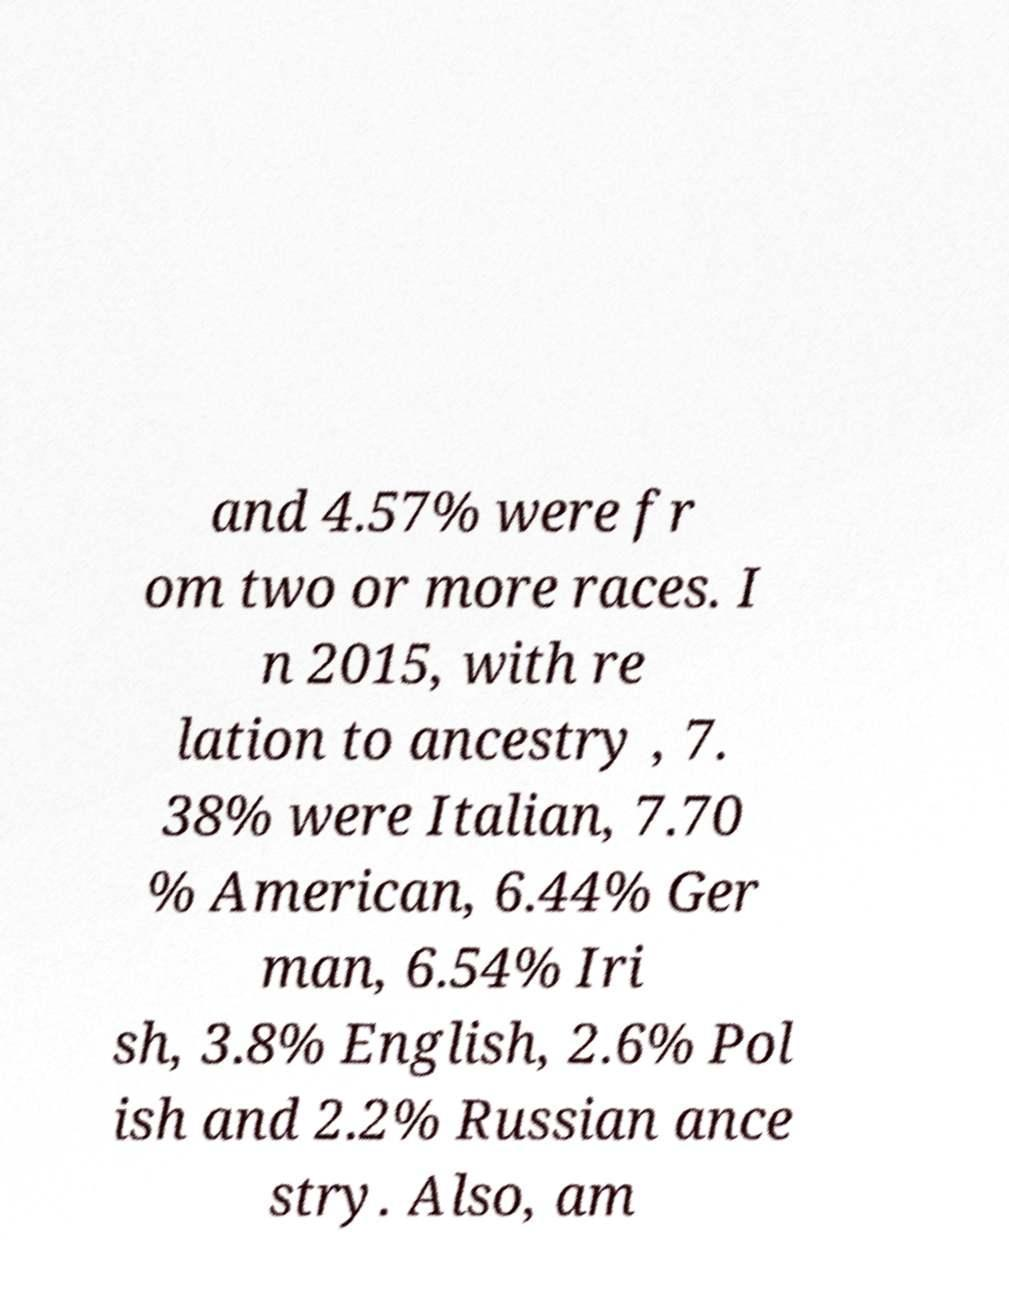Please identify and transcribe the text found in this image. and 4.57% were fr om two or more races. I n 2015, with re lation to ancestry , 7. 38% were Italian, 7.70 % American, 6.44% Ger man, 6.54% Iri sh, 3.8% English, 2.6% Pol ish and 2.2% Russian ance stry. Also, am 